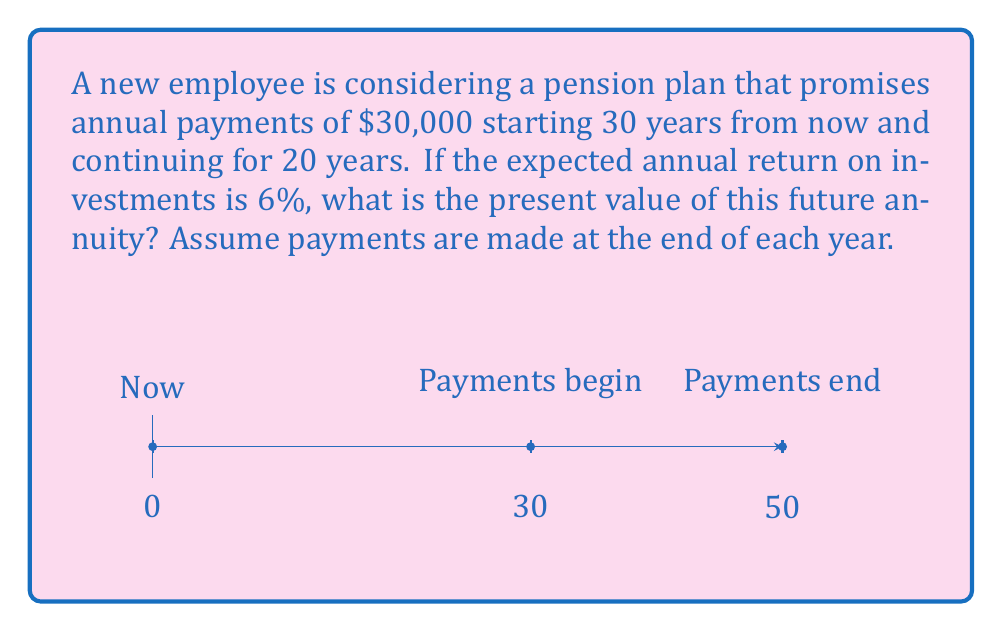Can you solve this math problem? To solve this problem, we'll use the present value of a delayed annuity formula:

$$PV = \frac{A}{r} \left(1 - \frac{1}{(1+r)^n}\right) \times \frac{1}{(1+r)^t}$$

Where:
$A$ = Annual payment
$r$ = Annual interest rate
$n$ = Number of years the annuity lasts
$t$ = Number of years until the annuity starts

Step 1: Identify the variables
$A = \$30,000$
$r = 6\% = 0.06$
$n = 20$ years
$t = 30$ years

Step 2: Plug the values into the formula
$$PV = \frac{30000}{0.06} \left(1 - \frac{1}{(1+0.06)^{20}}\right) \times \frac{1}{(1+0.06)^{30}}$$

Step 3: Calculate the inner part of the equation
$$\left(1 - \frac{1}{(1+0.06)^{20}}\right) = 1 - 0.3118 = 0.6882$$

Step 4: Calculate the delayed factor
$$\frac{1}{(1+0.06)^{30}} = 0.1741$$

Step 5: Put it all together
$$PV = \frac{30000}{0.06} \times 0.6882 \times 0.1741$$
$$PV = 500000 \times 0.6882 \times 0.1741$$
$$PV = 59,938.51$$

Therefore, the present value of the future annuity payments is approximately $59,938.51.
Answer: $59,938.51 